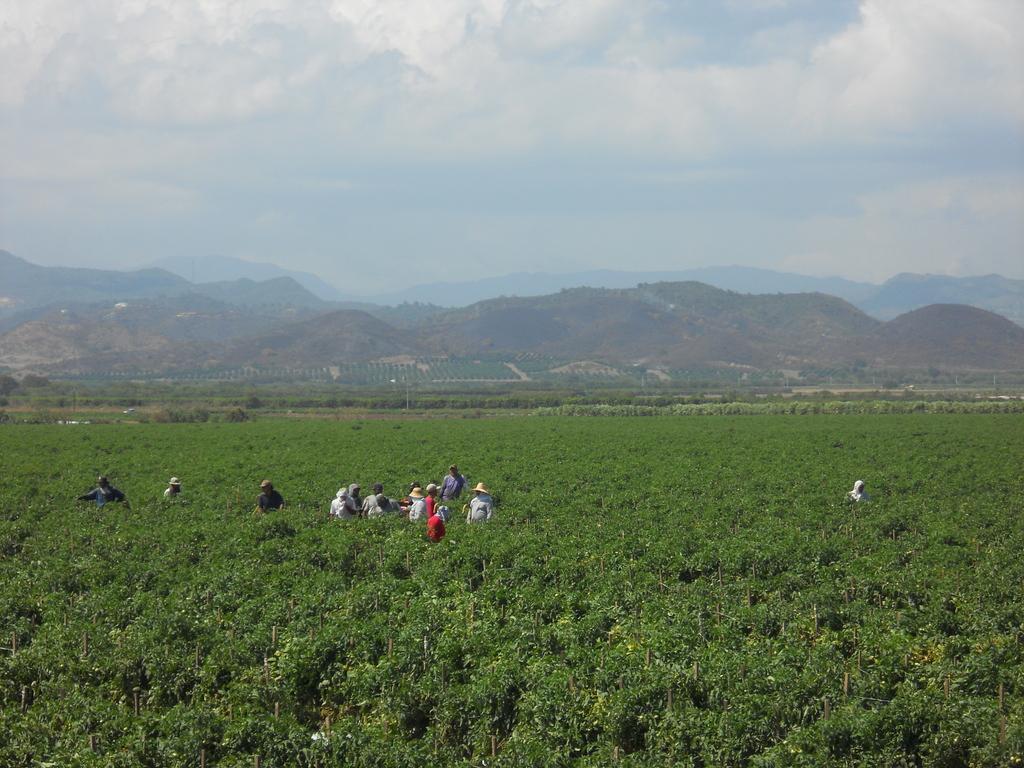In one or two sentences, can you explain what this image depicts? In the image there are few people standing in the middle of the plantation field, in the back there are hills with trees all over it and above its sky with clouds. 